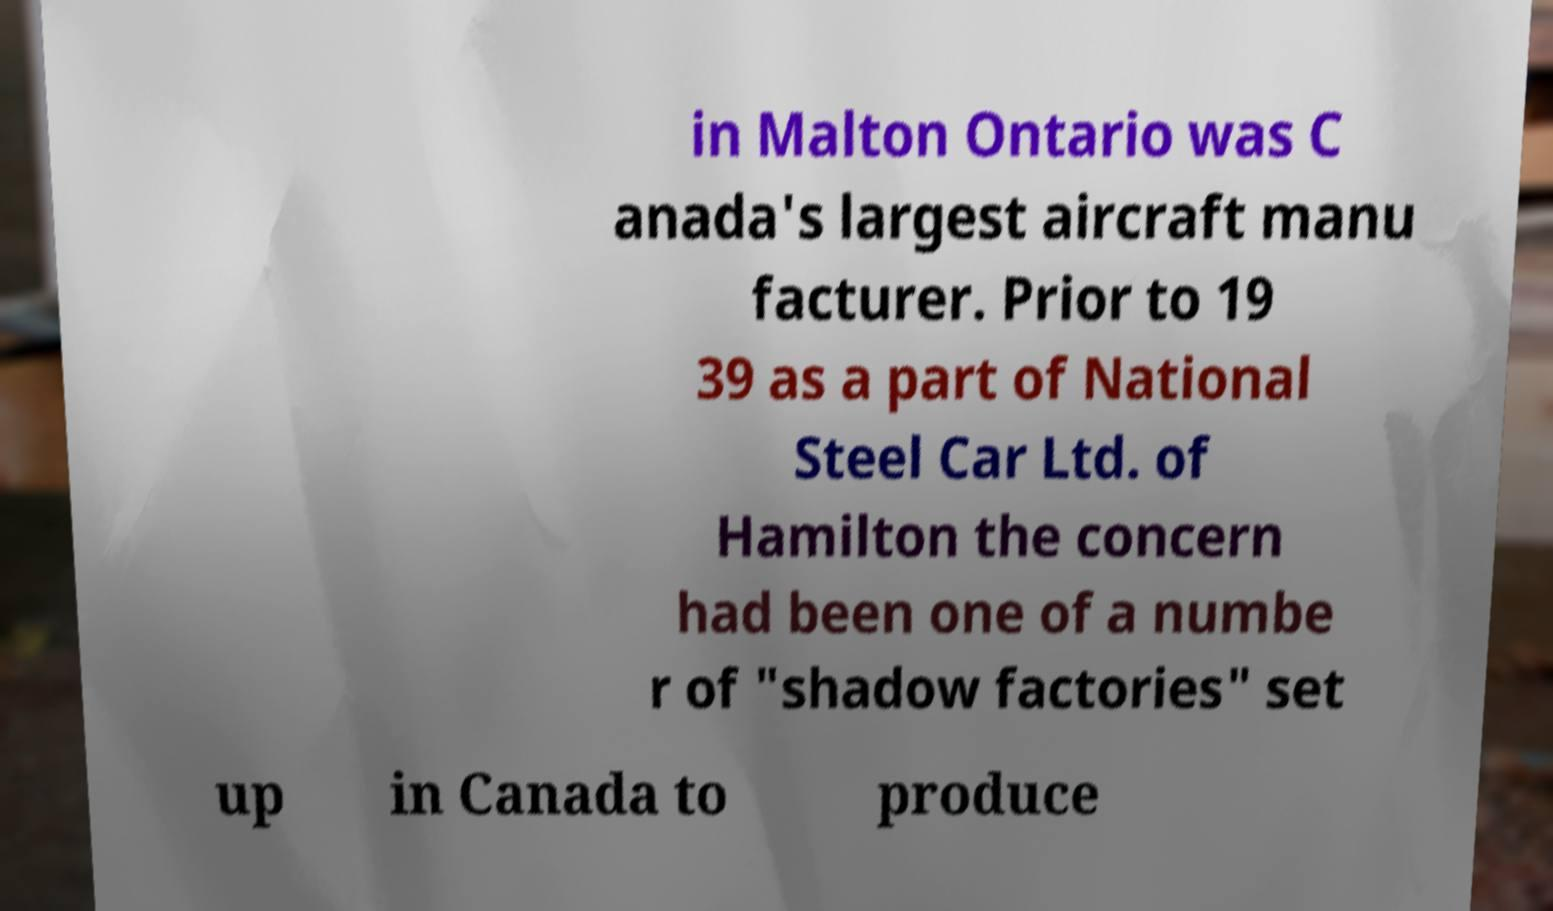What messages or text are displayed in this image? I need them in a readable, typed format. in Malton Ontario was C anada's largest aircraft manu facturer. Prior to 19 39 as a part of National Steel Car Ltd. of Hamilton the concern had been one of a numbe r of "shadow factories" set up in Canada to produce 